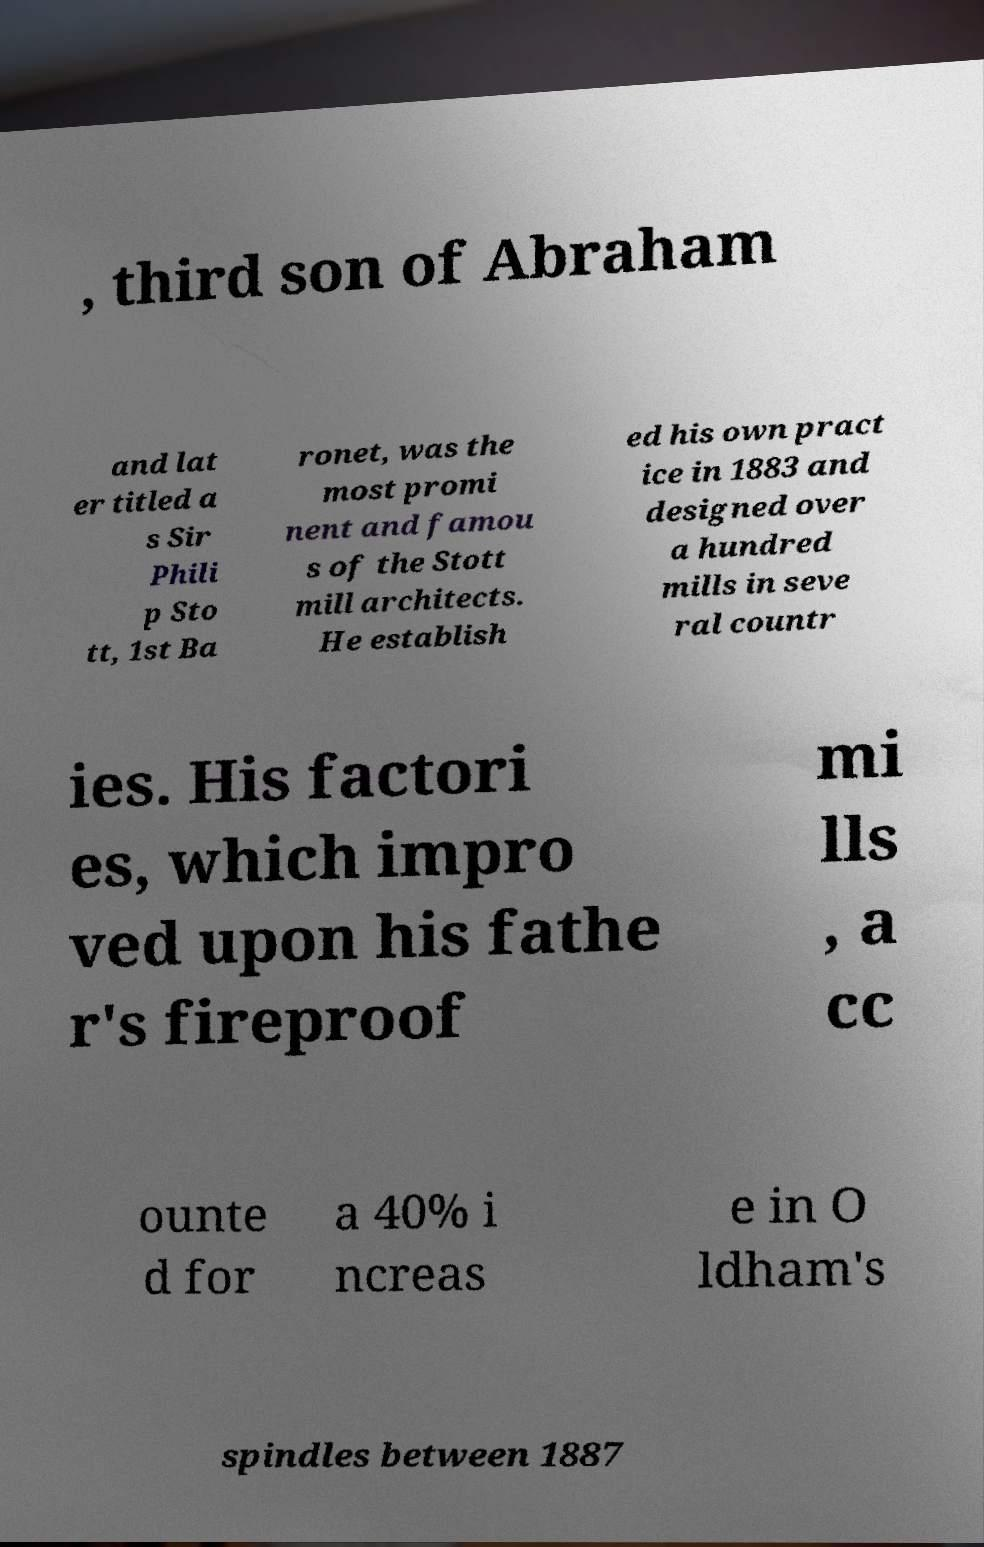Please identify and transcribe the text found in this image. , third son of Abraham and lat er titled a s Sir Phili p Sto tt, 1st Ba ronet, was the most promi nent and famou s of the Stott mill architects. He establish ed his own pract ice in 1883 and designed over a hundred mills in seve ral countr ies. His factori es, which impro ved upon his fathe r's fireproof mi lls , a cc ounte d for a 40% i ncreas e in O ldham's spindles between 1887 